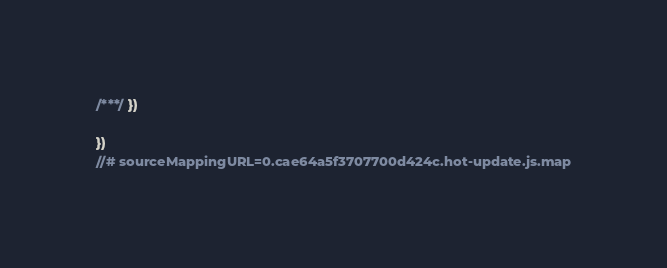<code> <loc_0><loc_0><loc_500><loc_500><_JavaScript_>/***/ })

})
//# sourceMappingURL=0.cae64a5f3707700d424c.hot-update.js.map</code> 